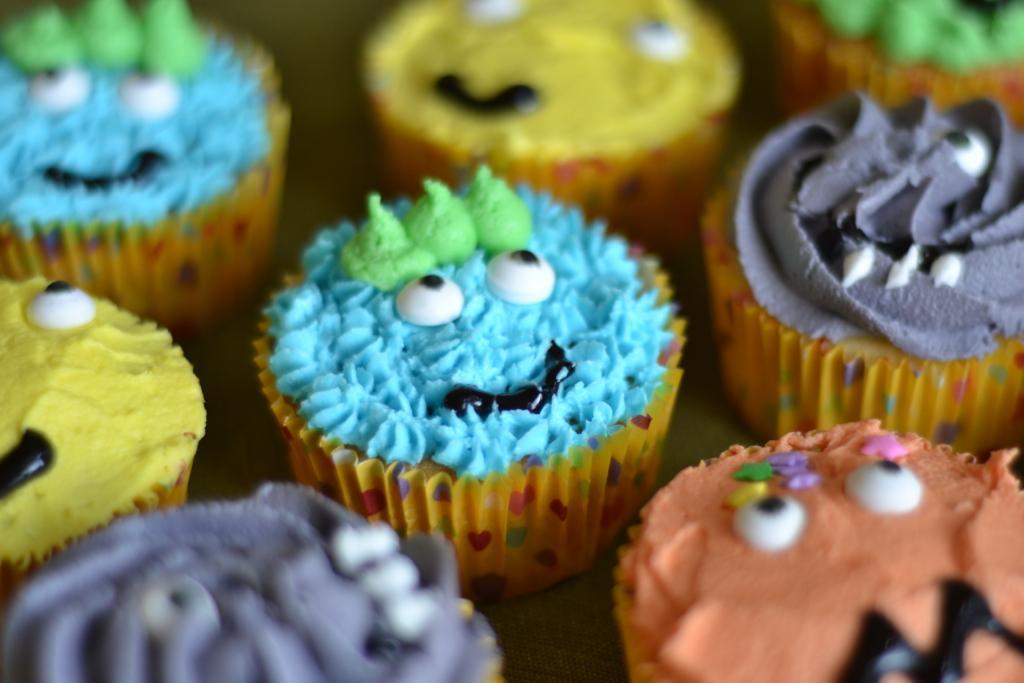In one or two sentences, can you explain what this image depicts? In the image in the center, we can see cupcakes and creams on it, which are in different colors. 